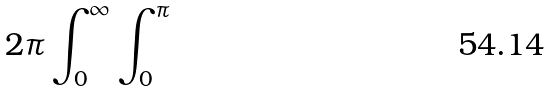<formula> <loc_0><loc_0><loc_500><loc_500>2 \pi \int _ { 0 } ^ { \infty } \int _ { 0 } ^ { \pi }</formula> 